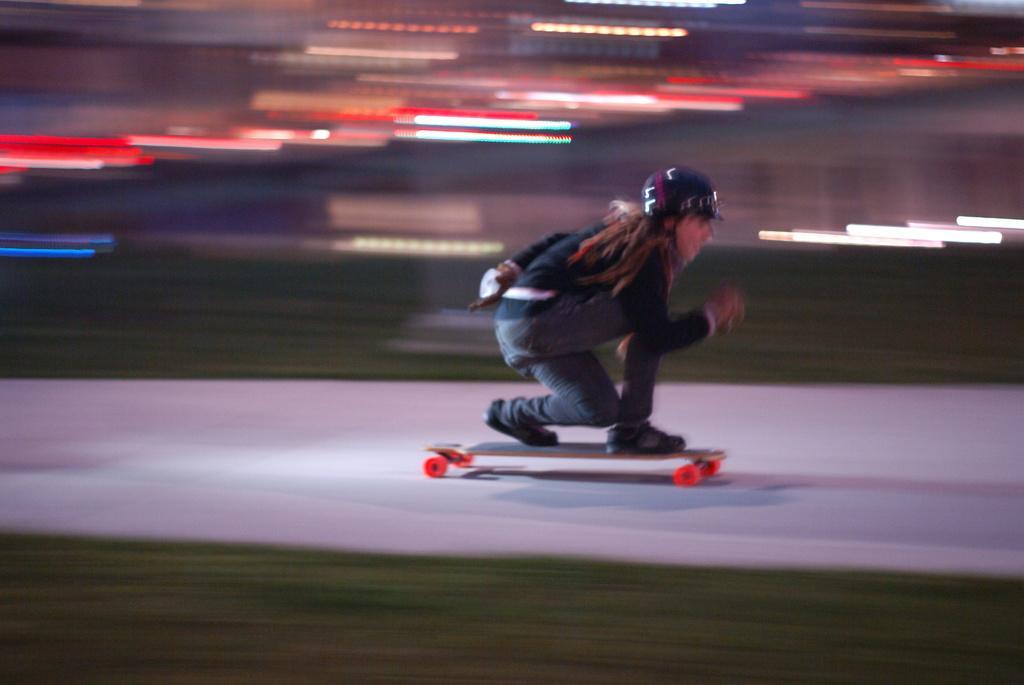Can you describe this image briefly? In this image we can see a person wearing dress and a helmet is standing on a skateboard placed on the ground. 